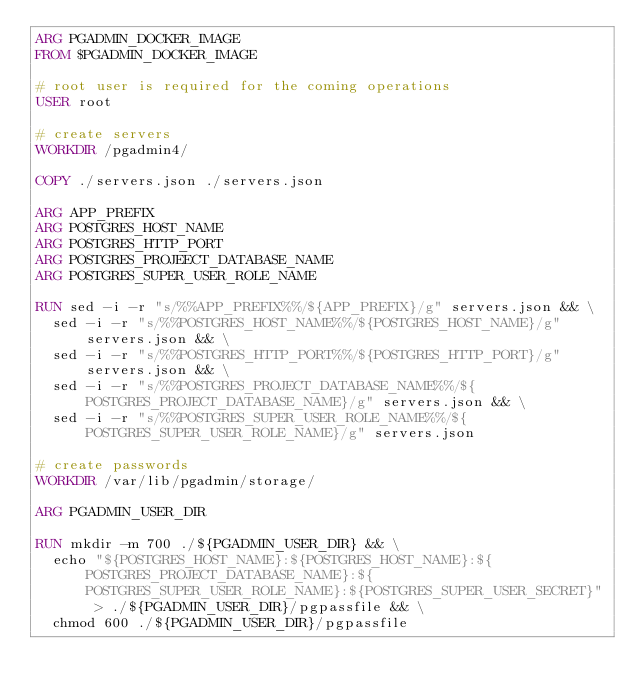Convert code to text. <code><loc_0><loc_0><loc_500><loc_500><_Dockerfile_>ARG PGADMIN_DOCKER_IMAGE
FROM $PGADMIN_DOCKER_IMAGE

# root user is required for the coming operations
USER root

# create servers
WORKDIR /pgadmin4/

COPY ./servers.json ./servers.json

ARG APP_PREFIX
ARG POSTGRES_HOST_NAME
ARG POSTGRES_HTTP_PORT
ARG POSTGRES_PROJEECT_DATABASE_NAME
ARG POSTGRES_SUPER_USER_ROLE_NAME

RUN sed -i -r "s/%%APP_PREFIX%%/${APP_PREFIX}/g" servers.json && \
  sed -i -r "s/%%POSTGRES_HOST_NAME%%/${POSTGRES_HOST_NAME}/g" servers.json && \
  sed -i -r "s/%%POSTGRES_HTTP_PORT%%/${POSTGRES_HTTP_PORT}/g" servers.json && \
  sed -i -r "s/%%POSTGRES_PROJECT_DATABASE_NAME%%/${POSTGRES_PROJECT_DATABASE_NAME}/g" servers.json && \
  sed -i -r "s/%%POSTGRES_SUPER_USER_ROLE_NAME%%/${POSTGRES_SUPER_USER_ROLE_NAME}/g" servers.json

# create passwords
WORKDIR /var/lib/pgadmin/storage/

ARG PGADMIN_USER_DIR

RUN mkdir -m 700 ./${PGADMIN_USER_DIR} && \
  echo "${POSTGRES_HOST_NAME}:${POSTGRES_HOST_NAME}:${POSTGRES_PROJECT_DATABASE_NAME}:${POSTGRES_SUPER_USER_ROLE_NAME}:${POSTGRES_SUPER_USER_SECRET}" > ./${PGADMIN_USER_DIR}/pgpassfile && \
  chmod 600 ./${PGADMIN_USER_DIR}/pgpassfile
</code> 